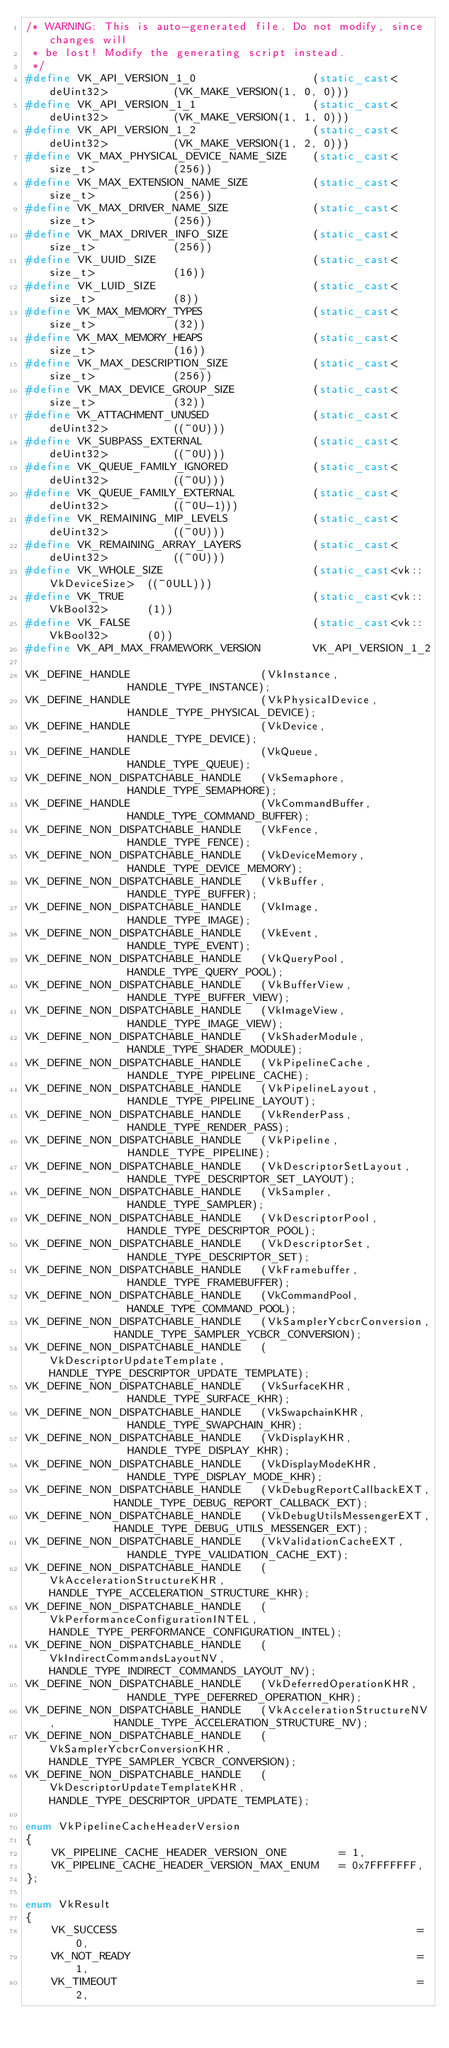Convert code to text. <code><loc_0><loc_0><loc_500><loc_500><_C++_>/* WARNING: This is auto-generated file. Do not modify, since changes will
 * be lost! Modify the generating script instead.
 */
#define VK_API_VERSION_1_0					(static_cast<deUint32>			(VK_MAKE_VERSION(1, 0, 0)))
#define VK_API_VERSION_1_1					(static_cast<deUint32>			(VK_MAKE_VERSION(1, 1, 0)))
#define VK_API_VERSION_1_2					(static_cast<deUint32>			(VK_MAKE_VERSION(1, 2, 0)))
#define VK_MAX_PHYSICAL_DEVICE_NAME_SIZE	(static_cast<size_t>			(256))
#define VK_MAX_EXTENSION_NAME_SIZE			(static_cast<size_t>			(256))
#define VK_MAX_DRIVER_NAME_SIZE				(static_cast<size_t>			(256))
#define VK_MAX_DRIVER_INFO_SIZE				(static_cast<size_t>			(256))
#define VK_UUID_SIZE						(static_cast<size_t>			(16))
#define VK_LUID_SIZE						(static_cast<size_t>			(8))
#define VK_MAX_MEMORY_TYPES					(static_cast<size_t>			(32))
#define VK_MAX_MEMORY_HEAPS					(static_cast<size_t>			(16))
#define VK_MAX_DESCRIPTION_SIZE				(static_cast<size_t>			(256))
#define VK_MAX_DEVICE_GROUP_SIZE			(static_cast<size_t>			(32))
#define VK_ATTACHMENT_UNUSED				(static_cast<deUint32>			((~0U)))
#define VK_SUBPASS_EXTERNAL					(static_cast<deUint32>			((~0U)))
#define VK_QUEUE_FAMILY_IGNORED				(static_cast<deUint32>			((~0U)))
#define VK_QUEUE_FAMILY_EXTERNAL			(static_cast<deUint32>			((~0U-1)))
#define VK_REMAINING_MIP_LEVELS				(static_cast<deUint32>			((~0U)))
#define VK_REMAINING_ARRAY_LAYERS			(static_cast<deUint32>			((~0U)))
#define VK_WHOLE_SIZE						(static_cast<vk::VkDeviceSize>	((~0ULL)))
#define VK_TRUE								(static_cast<vk::VkBool32>		(1))
#define VK_FALSE							(static_cast<vk::VkBool32>		(0))
#define VK_API_MAX_FRAMEWORK_VERSION		VK_API_VERSION_1_2

VK_DEFINE_HANDLE					(VkInstance,						HANDLE_TYPE_INSTANCE);
VK_DEFINE_HANDLE					(VkPhysicalDevice,					HANDLE_TYPE_PHYSICAL_DEVICE);
VK_DEFINE_HANDLE					(VkDevice,							HANDLE_TYPE_DEVICE);
VK_DEFINE_HANDLE					(VkQueue,							HANDLE_TYPE_QUEUE);
VK_DEFINE_NON_DISPATCHABLE_HANDLE	(VkSemaphore,						HANDLE_TYPE_SEMAPHORE);
VK_DEFINE_HANDLE					(VkCommandBuffer,					HANDLE_TYPE_COMMAND_BUFFER);
VK_DEFINE_NON_DISPATCHABLE_HANDLE	(VkFence,							HANDLE_TYPE_FENCE);
VK_DEFINE_NON_DISPATCHABLE_HANDLE	(VkDeviceMemory,					HANDLE_TYPE_DEVICE_MEMORY);
VK_DEFINE_NON_DISPATCHABLE_HANDLE	(VkBuffer,							HANDLE_TYPE_BUFFER);
VK_DEFINE_NON_DISPATCHABLE_HANDLE	(VkImage,							HANDLE_TYPE_IMAGE);
VK_DEFINE_NON_DISPATCHABLE_HANDLE	(VkEvent,							HANDLE_TYPE_EVENT);
VK_DEFINE_NON_DISPATCHABLE_HANDLE	(VkQueryPool,						HANDLE_TYPE_QUERY_POOL);
VK_DEFINE_NON_DISPATCHABLE_HANDLE	(VkBufferView,						HANDLE_TYPE_BUFFER_VIEW);
VK_DEFINE_NON_DISPATCHABLE_HANDLE	(VkImageView,						HANDLE_TYPE_IMAGE_VIEW);
VK_DEFINE_NON_DISPATCHABLE_HANDLE	(VkShaderModule,					HANDLE_TYPE_SHADER_MODULE);
VK_DEFINE_NON_DISPATCHABLE_HANDLE	(VkPipelineCache,					HANDLE_TYPE_PIPELINE_CACHE);
VK_DEFINE_NON_DISPATCHABLE_HANDLE	(VkPipelineLayout,					HANDLE_TYPE_PIPELINE_LAYOUT);
VK_DEFINE_NON_DISPATCHABLE_HANDLE	(VkRenderPass,						HANDLE_TYPE_RENDER_PASS);
VK_DEFINE_NON_DISPATCHABLE_HANDLE	(VkPipeline,						HANDLE_TYPE_PIPELINE);
VK_DEFINE_NON_DISPATCHABLE_HANDLE	(VkDescriptorSetLayout,				HANDLE_TYPE_DESCRIPTOR_SET_LAYOUT);
VK_DEFINE_NON_DISPATCHABLE_HANDLE	(VkSampler,							HANDLE_TYPE_SAMPLER);
VK_DEFINE_NON_DISPATCHABLE_HANDLE	(VkDescriptorPool,					HANDLE_TYPE_DESCRIPTOR_POOL);
VK_DEFINE_NON_DISPATCHABLE_HANDLE	(VkDescriptorSet,					HANDLE_TYPE_DESCRIPTOR_SET);
VK_DEFINE_NON_DISPATCHABLE_HANDLE	(VkFramebuffer,						HANDLE_TYPE_FRAMEBUFFER);
VK_DEFINE_NON_DISPATCHABLE_HANDLE	(VkCommandPool,						HANDLE_TYPE_COMMAND_POOL);
VK_DEFINE_NON_DISPATCHABLE_HANDLE	(VkSamplerYcbcrConversion,			HANDLE_TYPE_SAMPLER_YCBCR_CONVERSION);
VK_DEFINE_NON_DISPATCHABLE_HANDLE	(VkDescriptorUpdateTemplate,		HANDLE_TYPE_DESCRIPTOR_UPDATE_TEMPLATE);
VK_DEFINE_NON_DISPATCHABLE_HANDLE	(VkSurfaceKHR,						HANDLE_TYPE_SURFACE_KHR);
VK_DEFINE_NON_DISPATCHABLE_HANDLE	(VkSwapchainKHR,					HANDLE_TYPE_SWAPCHAIN_KHR);
VK_DEFINE_NON_DISPATCHABLE_HANDLE	(VkDisplayKHR,						HANDLE_TYPE_DISPLAY_KHR);
VK_DEFINE_NON_DISPATCHABLE_HANDLE	(VkDisplayModeKHR,					HANDLE_TYPE_DISPLAY_MODE_KHR);
VK_DEFINE_NON_DISPATCHABLE_HANDLE	(VkDebugReportCallbackEXT,			HANDLE_TYPE_DEBUG_REPORT_CALLBACK_EXT);
VK_DEFINE_NON_DISPATCHABLE_HANDLE	(VkDebugUtilsMessengerEXT,			HANDLE_TYPE_DEBUG_UTILS_MESSENGER_EXT);
VK_DEFINE_NON_DISPATCHABLE_HANDLE	(VkValidationCacheEXT,				HANDLE_TYPE_VALIDATION_CACHE_EXT);
VK_DEFINE_NON_DISPATCHABLE_HANDLE	(VkAccelerationStructureKHR,		HANDLE_TYPE_ACCELERATION_STRUCTURE_KHR);
VK_DEFINE_NON_DISPATCHABLE_HANDLE	(VkPerformanceConfigurationINTEL,	HANDLE_TYPE_PERFORMANCE_CONFIGURATION_INTEL);
VK_DEFINE_NON_DISPATCHABLE_HANDLE	(VkIndirectCommandsLayoutNV,		HANDLE_TYPE_INDIRECT_COMMANDS_LAYOUT_NV);
VK_DEFINE_NON_DISPATCHABLE_HANDLE	(VkDeferredOperationKHR,			HANDLE_TYPE_DEFERRED_OPERATION_KHR);
VK_DEFINE_NON_DISPATCHABLE_HANDLE	(VkAccelerationStructureNV,			HANDLE_TYPE_ACCELERATION_STRUCTURE_NV);
VK_DEFINE_NON_DISPATCHABLE_HANDLE	(VkSamplerYcbcrConversionKHR,		HANDLE_TYPE_SAMPLER_YCBCR_CONVERSION);
VK_DEFINE_NON_DISPATCHABLE_HANDLE	(VkDescriptorUpdateTemplateKHR,		HANDLE_TYPE_DESCRIPTOR_UPDATE_TEMPLATE);

enum VkPipelineCacheHeaderVersion
{
	VK_PIPELINE_CACHE_HEADER_VERSION_ONE		= 1,
	VK_PIPELINE_CACHE_HEADER_VERSION_MAX_ENUM	= 0x7FFFFFFF,
};

enum VkResult
{
	VK_SUCCESS												= 0,
	VK_NOT_READY											= 1,
	VK_TIMEOUT												= 2,</code> 